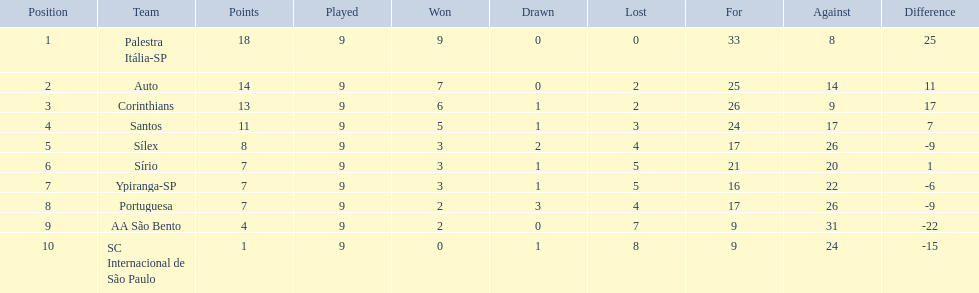How many teams played football in brazil during the year 1926? Palestra Itália-SP, Auto, Corinthians, Santos, Sílex, Sírio, Ypiranga-SP, Portuguesa, AA São Bento, SC Internacional de São Paulo. What was the highest number of games won during the 1926 season? 9. Which team was in the top spot with 9 wins for the 1926 season? Palestra Itália-SP. 